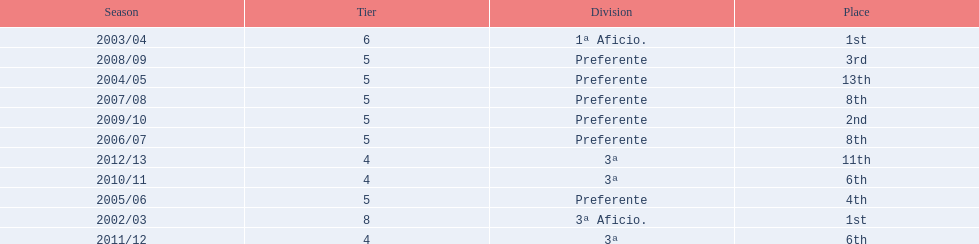Which division placed more than aficio 1a and 3a? Preferente. 